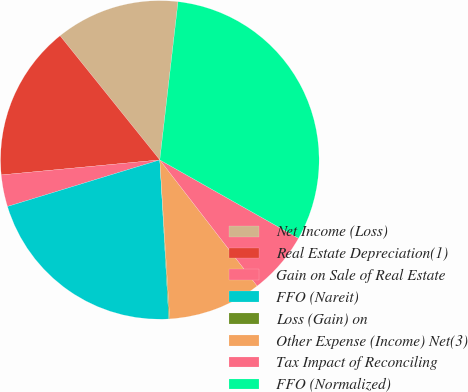Convert chart to OTSL. <chart><loc_0><loc_0><loc_500><loc_500><pie_chart><fcel>Net Income (Loss)<fcel>Real Estate Depreciation(1)<fcel>Gain on Sale of Real Estate<fcel>FFO (Nareit)<fcel>Loss (Gain) on<fcel>Other Expense (Income) Net(3)<fcel>Tax Impact of Reconciling<fcel>FFO (Normalized)<nl><fcel>12.6%<fcel>15.73%<fcel>3.22%<fcel>21.18%<fcel>0.09%<fcel>9.47%<fcel>6.35%<fcel>31.36%<nl></chart> 